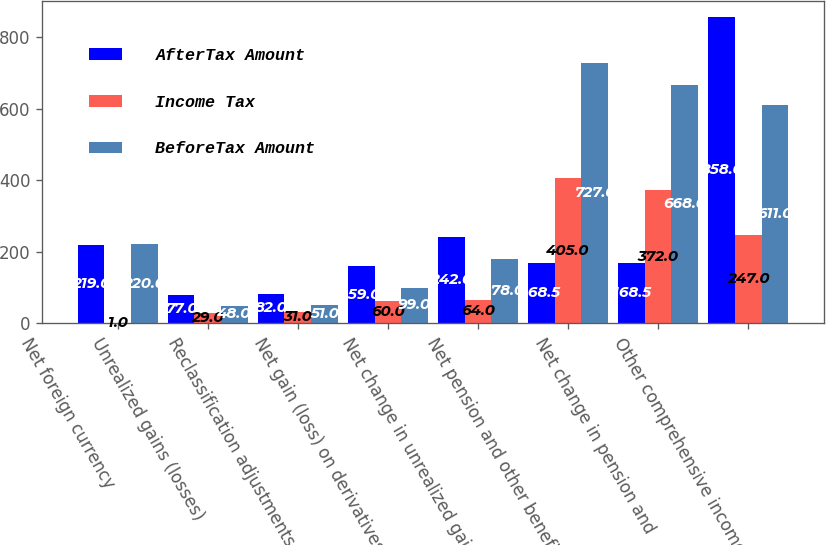<chart> <loc_0><loc_0><loc_500><loc_500><stacked_bar_chart><ecel><fcel>Net foreign currency<fcel>Unrealized gains (losses)<fcel>Reclassification adjustments<fcel>Net gain (loss) on derivatives<fcel>Net change in unrealized gain<fcel>Net pension and other benefits<fcel>Net change in pension and<fcel>Other comprehensive income<nl><fcel>AfterTax Amount<fcel>219<fcel>77<fcel>82<fcel>159<fcel>242<fcel>168.5<fcel>168.5<fcel>858<nl><fcel>Income Tax<fcel>1<fcel>29<fcel>31<fcel>60<fcel>64<fcel>405<fcel>372<fcel>247<nl><fcel>BeforeTax Amount<fcel>220<fcel>48<fcel>51<fcel>99<fcel>178<fcel>727<fcel>668<fcel>611<nl></chart> 